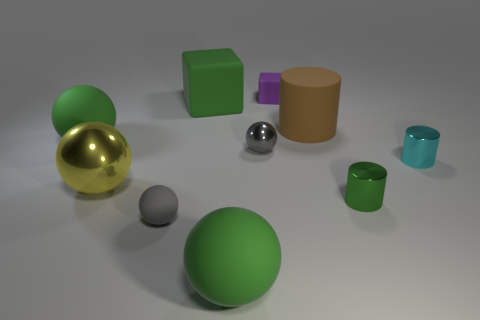Subtract all green spheres. How many spheres are left? 3 Subtract 1 balls. How many balls are left? 4 Subtract all small matte balls. How many balls are left? 4 Subtract all blue spheres. Subtract all cyan cylinders. How many spheres are left? 5 Subtract all cubes. How many objects are left? 8 Add 6 tiny purple blocks. How many tiny purple blocks are left? 7 Add 6 small gray rubber spheres. How many small gray rubber spheres exist? 7 Subtract 0 blue balls. How many objects are left? 10 Subtract all large red shiny blocks. Subtract all metallic spheres. How many objects are left? 8 